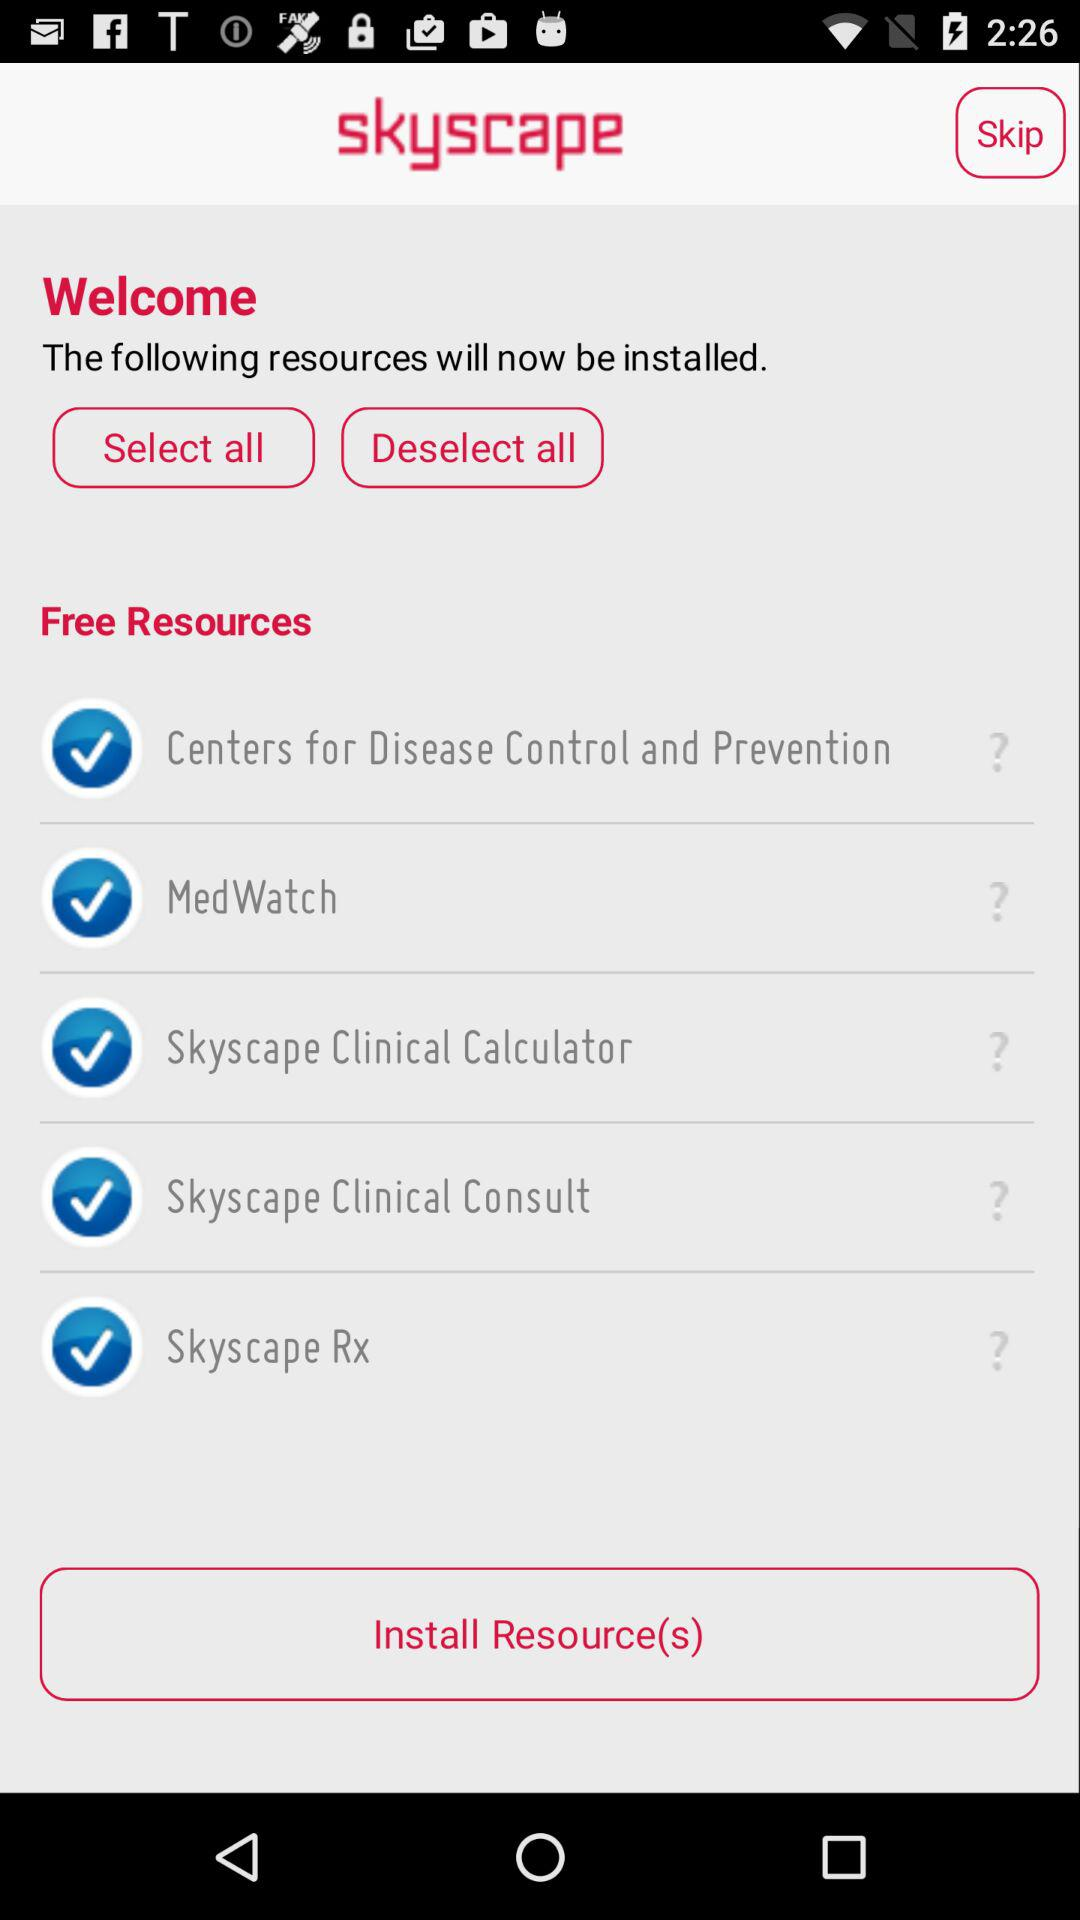How many resources will be installed?
Answer the question using a single word or phrase. 5 